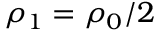<formula> <loc_0><loc_0><loc_500><loc_500>\rho _ { 1 } = \rho _ { 0 } / 2</formula> 